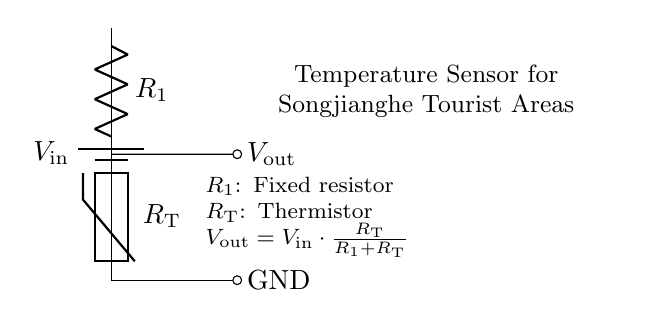What is the input voltage in this circuit? The input voltage, indicated as V_in, is the voltage provided to the circuit. This value is systemic to the operation of the circuit but is not specified in the diagram itself; commonly, it's assumed to be a standard voltage like 5 or 12 volts.
Answer: V_in What type of resistor is R_T? R_T is labeled as a thermistor, which is a type of resistor whose resistance varies significantly with temperature. This means it can sense temperature changes in the environment.
Answer: Thermistor What do R_1 and R_T form in this circuit? R_1 and R_T form a voltage divider configuration, where the output voltage can be adjusted based on the resistance values of these two components and is used for temperature sensing.
Answer: Voltage divider What is the formula for V_out in this circuit? The formula given in the diagram specifies how to calculate the output voltage based on the resistances and input voltage, shown as V_out = V_in * (R_T / (R_1 + R_T)). This equation defines the relationship in a voltage divider circuit.
Answer: V_out = V_in * (R_T / (R_1 + R_T)) If R_1 = 1 kilo-ohm and R_T = 2 kilo-ohms, what is V_out in relation to V_in? To find V_out, we substitute the values into the formula: V_out = V_in * (R_T / (R_1 + R_T)) = V_in * (2 / (1 + 2)) = V_in * (2/3). The output voltage is thus two-thirds of the input voltage.
Answer: V_out = V_in * (2/3) 